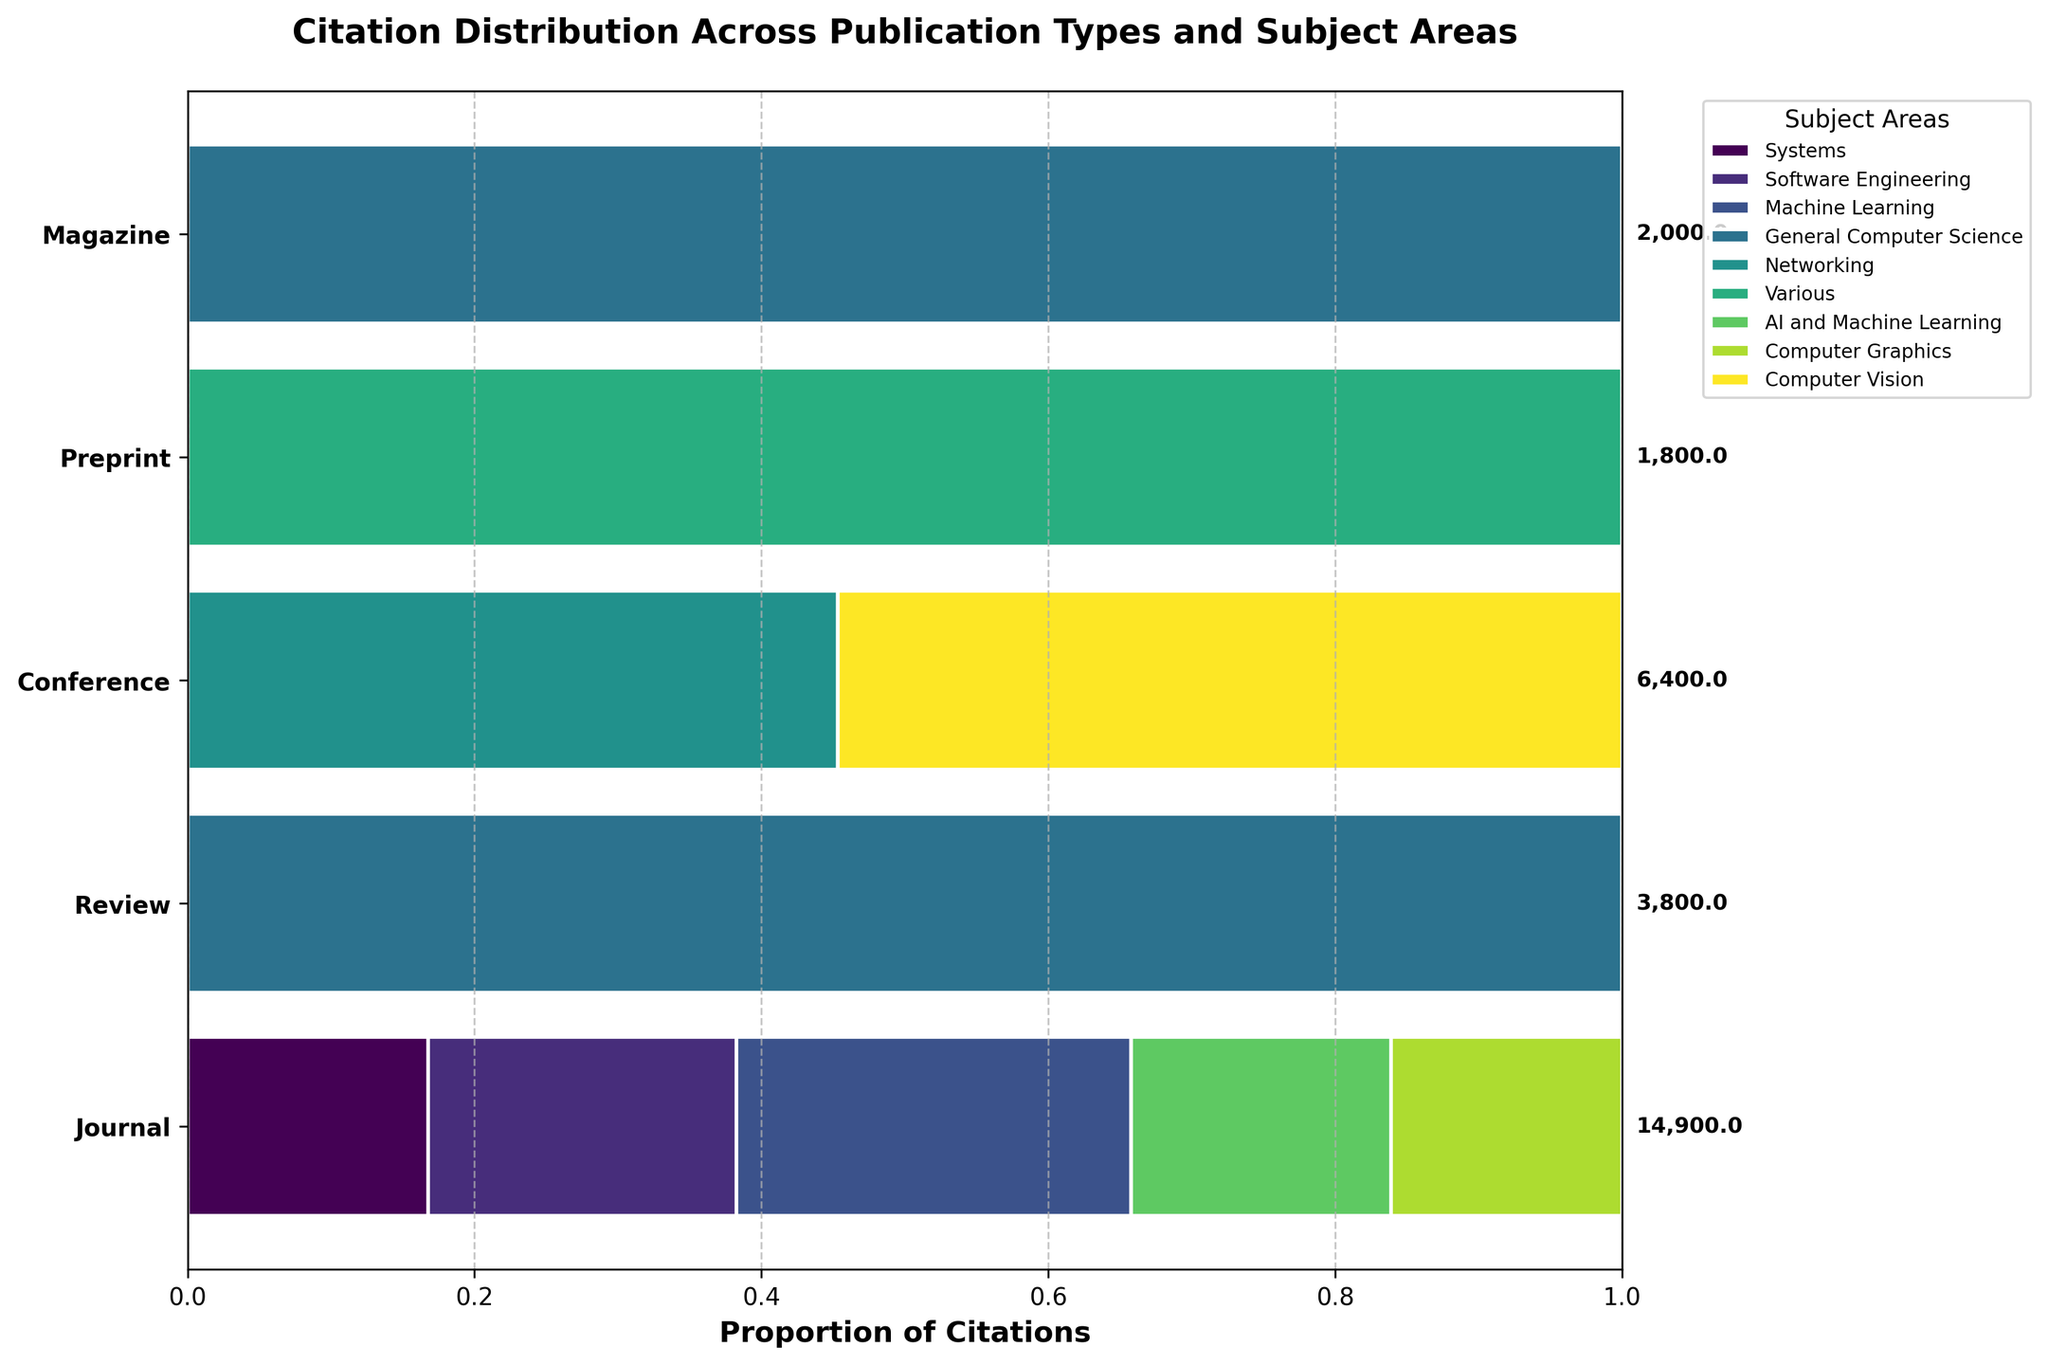What's the title of the figure? The title is usually placed at the top of the figure in a prominent position, and it provides an overview of what the figure is about.
Answer: Citation Distribution Across Publication Types and Subject Areas Which publication type has the highest total citation count? Look for the publication type with the longest total bar in the horizontal direction and the highest total citation count appearing as text to the right of the bar.
Answer: Journal What is the proportion of citations in the 'Machine Learning' subject area for 'Journal' publication types? Identify the segment corresponding to the 'Machine Learning' subject area in the 'Journal' bar. Measure its proportion visually or based on the width of the bar compared to the total width.
Answer: Around 41% Of the publication types 'Journal' and 'Conference,' which has more citations in the 'Networking' subject area? Compare the 'Networking' sections in the 'Journal' and 'Conference' bars by comparing the lengths of their segments.
Answer: Conference What is the total citation count for the 'Preprint' publication type? The total citation count is displayed as a text to the right end of the 'Preprint' bar.
Answer: 1800 Which subject area has the highest proportion of citations in 'ACM Computing Surveys'? Given 'ACM Computing Surveys' is categorized under 'Review,' determine the largest proportion segment in the 'Review' bar corresponding to the discussed journal.
Answer: General Computer Science How many different subject areas are represented in the figure? Count the number of different colors/segments in the figure's legend or within the bars representing different subject areas.
Answer: 6 What is the combined citation count for 'Computer Vision' subject area across all publication types? Sum up the lengths of all segments in each bar for the 'Computer Vision' subject area, or add the values if given in the original data.
Answer: 3500 Is the proportion of 'AI and Machine Learning' citations higher in 'Journal' or 'Conference' publications? Compare the relative proportions of the 'AI and Machine Learning' segments within the 'Journal' and 'Conference' bars by assessing visually or measuring widths.
Answer: Journal What color represents the 'Software Engineering' subject area, and which publication type includes this subject area? Identify the color linked to 'Software Engineering' in the legend and check which publication type's bar has this color segment.
Answer: Green, Journal 